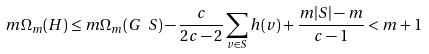<formula> <loc_0><loc_0><loc_500><loc_500>m \Omega _ { m } ( H ) \leq m \Omega _ { m } ( G \ S ) - \frac { c } { 2 c - 2 } \sum _ { v \in S } h ( v ) + \frac { m | S | - m } { c - 1 } < m + 1</formula> 